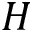<formula> <loc_0><loc_0><loc_500><loc_500>H</formula> 